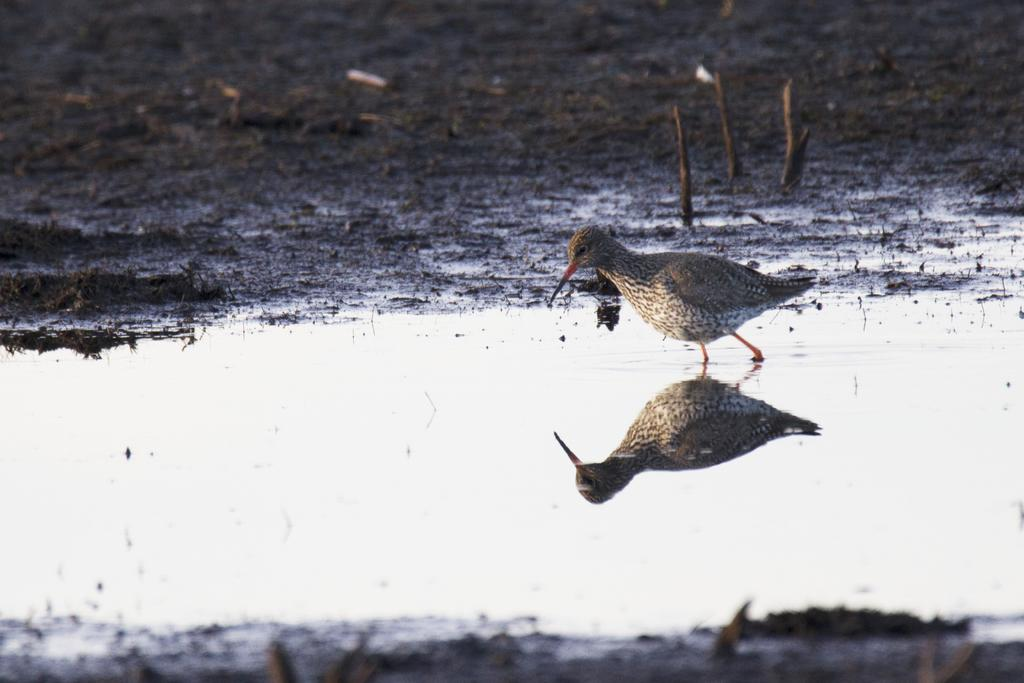What is the main subject of the picture? The main subject of the picture is a bird. What is the bird doing in the image? The bird is walking in the water. What can be seen in the background of the image? There is an open land in the background of the image. What type of record can be seen spinning in the image? There is no record present in the image; it features a bird walking in the water with an open land in the background. 